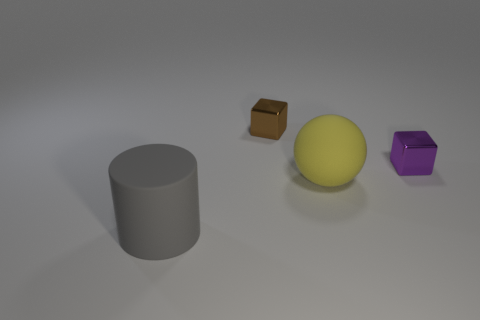Add 1 metallic cubes. How many objects exist? 5 Subtract all cylinders. How many objects are left? 3 Add 1 purple things. How many purple things are left? 2 Add 2 yellow matte objects. How many yellow matte objects exist? 3 Subtract 0 yellow cylinders. How many objects are left? 4 Subtract all red cylinders. Subtract all green spheres. How many cylinders are left? 1 Subtract all tiny yellow metal cylinders. Subtract all big spheres. How many objects are left? 3 